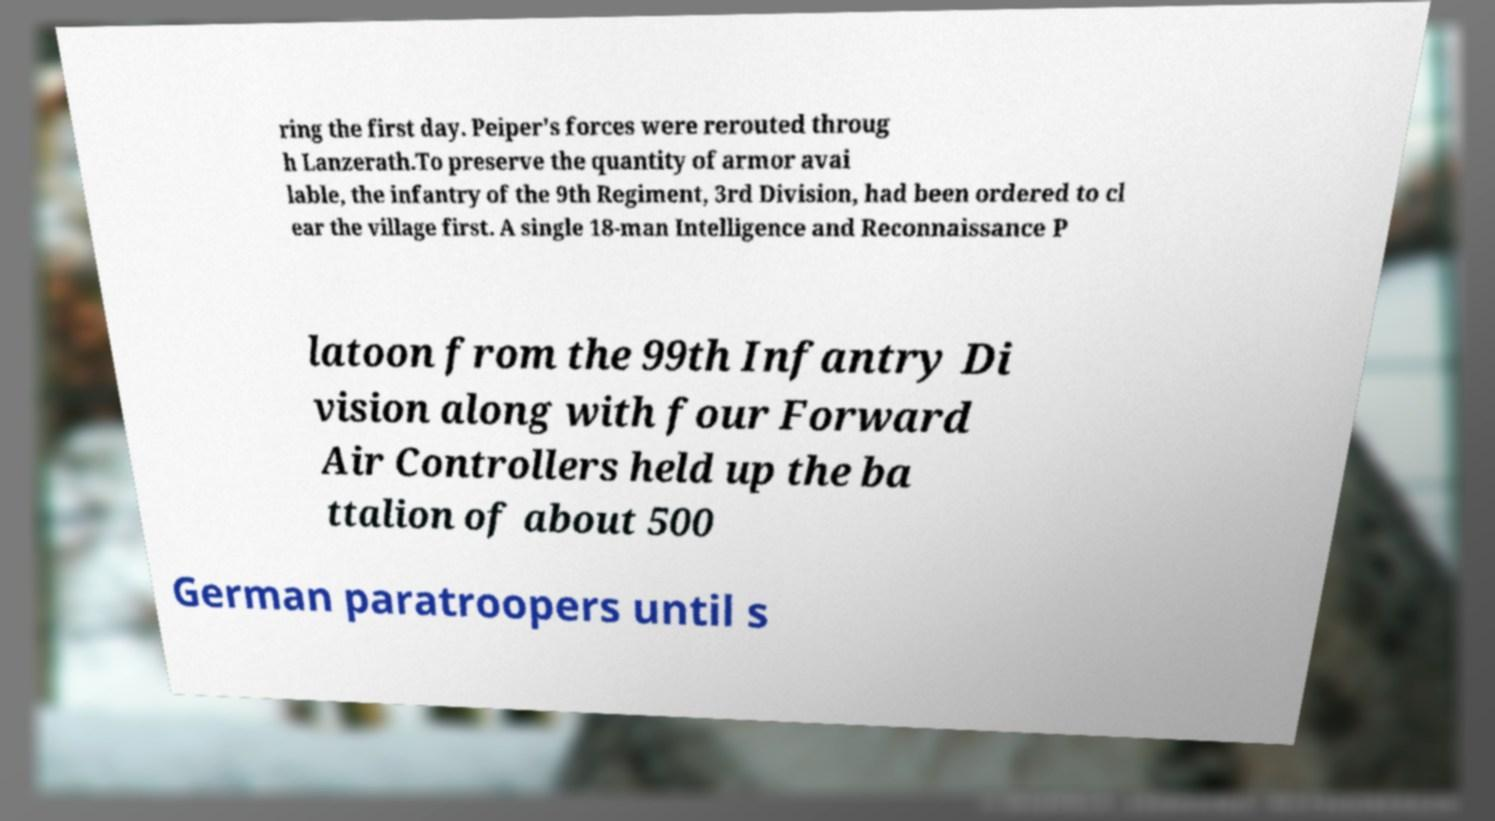What messages or text are displayed in this image? I need them in a readable, typed format. ring the first day. Peiper's forces were rerouted throug h Lanzerath.To preserve the quantity of armor avai lable, the infantry of the 9th Regiment, 3rd Division, had been ordered to cl ear the village first. A single 18-man Intelligence and Reconnaissance P latoon from the 99th Infantry Di vision along with four Forward Air Controllers held up the ba ttalion of about 500 German paratroopers until s 